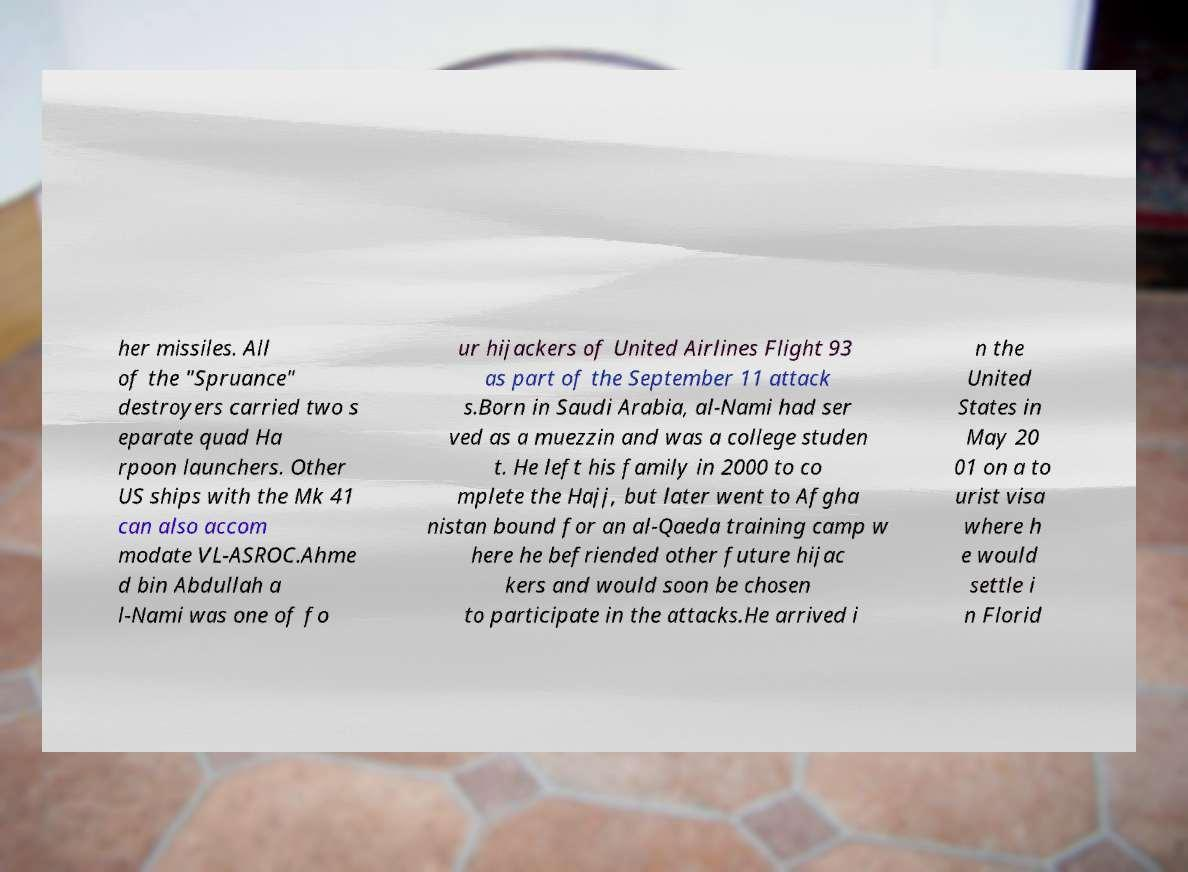Could you extract and type out the text from this image? her missiles. All of the "Spruance" destroyers carried two s eparate quad Ha rpoon launchers. Other US ships with the Mk 41 can also accom modate VL-ASROC.Ahme d bin Abdullah a l-Nami was one of fo ur hijackers of United Airlines Flight 93 as part of the September 11 attack s.Born in Saudi Arabia, al-Nami had ser ved as a muezzin and was a college studen t. He left his family in 2000 to co mplete the Hajj, but later went to Afgha nistan bound for an al-Qaeda training camp w here he befriended other future hijac kers and would soon be chosen to participate in the attacks.He arrived i n the United States in May 20 01 on a to urist visa where h e would settle i n Florid 